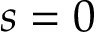<formula> <loc_0><loc_0><loc_500><loc_500>s = 0</formula> 